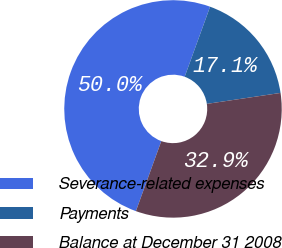<chart> <loc_0><loc_0><loc_500><loc_500><pie_chart><fcel>Severance-related expenses<fcel>Payments<fcel>Balance at December 31 2008<nl><fcel>50.0%<fcel>17.11%<fcel>32.89%<nl></chart> 